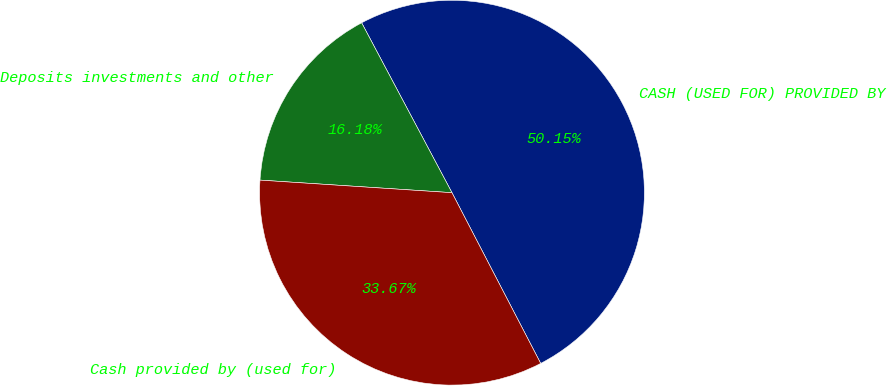<chart> <loc_0><loc_0><loc_500><loc_500><pie_chart><fcel>CASH (USED FOR) PROVIDED BY<fcel>Deposits investments and other<fcel>Cash provided by (used for)<nl><fcel>50.15%<fcel>16.18%<fcel>33.67%<nl></chart> 